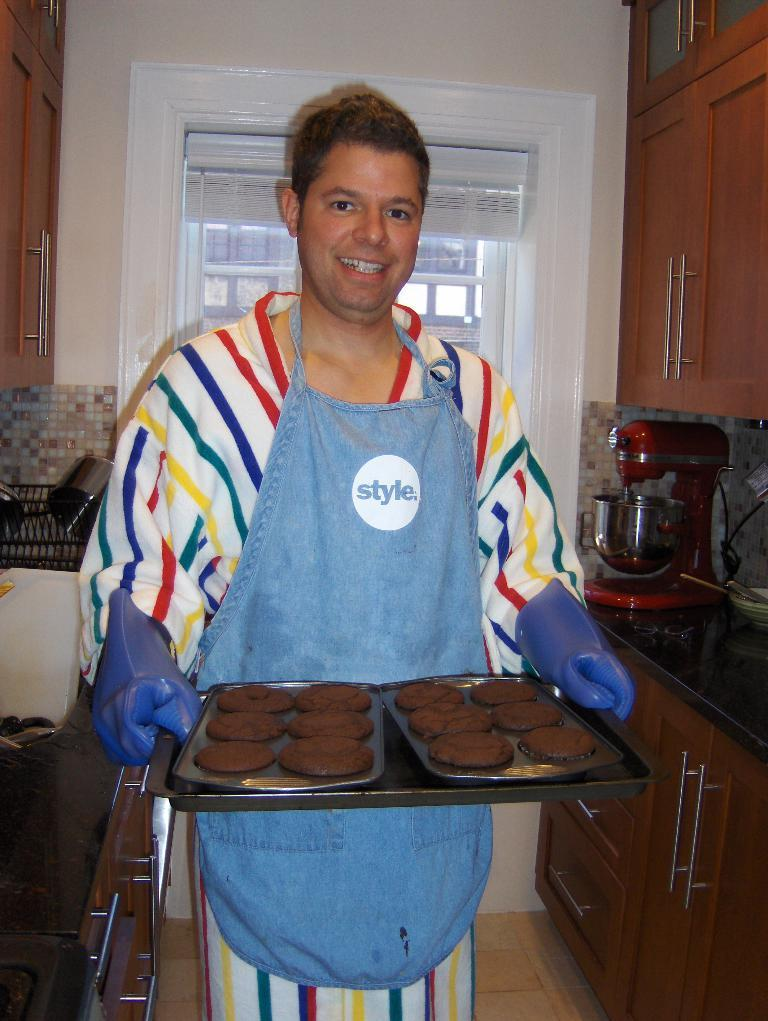<image>
Present a compact description of the photo's key features. a man with an apron that reads 'style' is holding brownies 